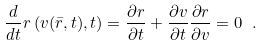Convert formula to latex. <formula><loc_0><loc_0><loc_500><loc_500>\frac { d } { d t } r \left ( v ( \bar { r } , t ) , t \right ) = \frac { \partial r } { \partial t } + \frac { \partial v } { \partial t } \frac { \partial r } { \partial v } = 0 \ .</formula> 